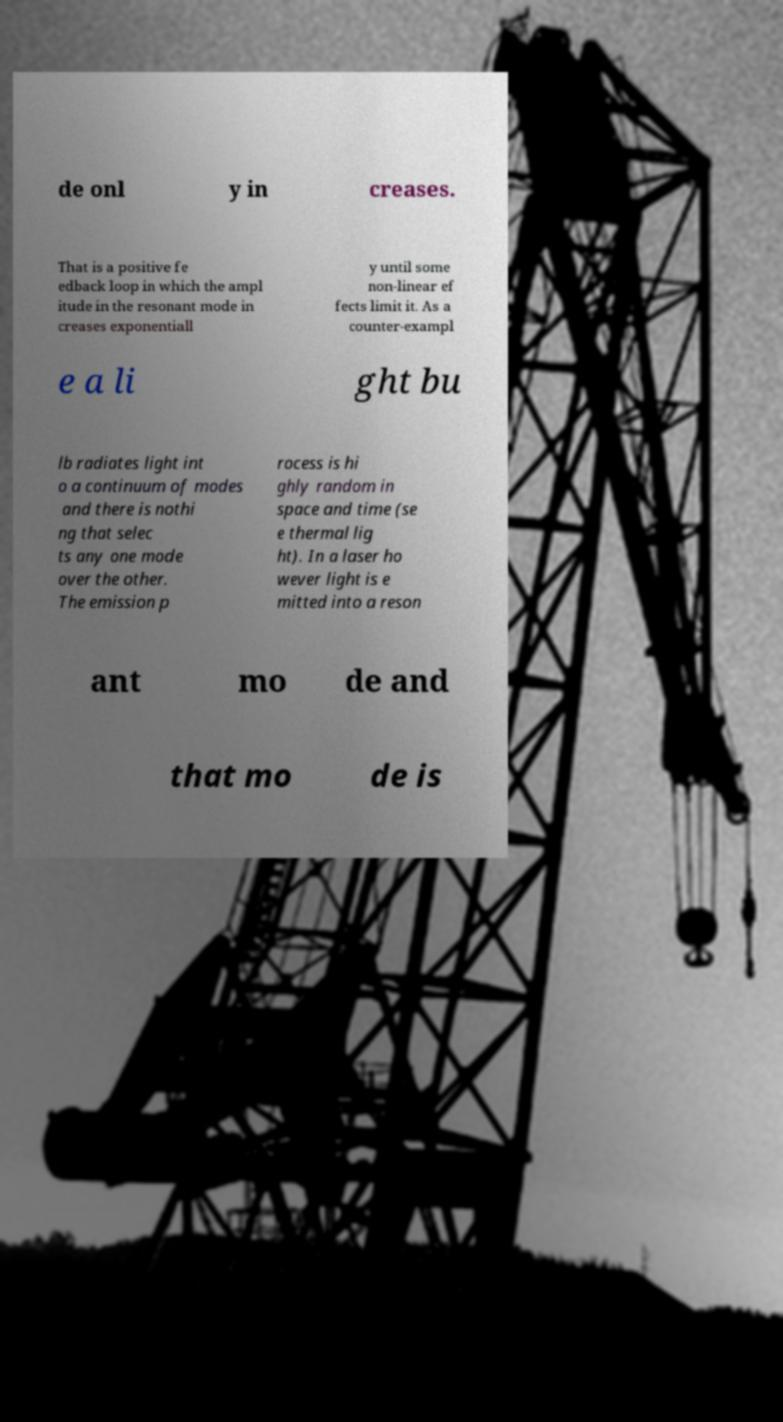Please read and relay the text visible in this image. What does it say? de onl y in creases. That is a positive fe edback loop in which the ampl itude in the resonant mode in creases exponentiall y until some non-linear ef fects limit it. As a counter-exampl e a li ght bu lb radiates light int o a continuum of modes and there is nothi ng that selec ts any one mode over the other. The emission p rocess is hi ghly random in space and time (se e thermal lig ht). In a laser ho wever light is e mitted into a reson ant mo de and that mo de is 